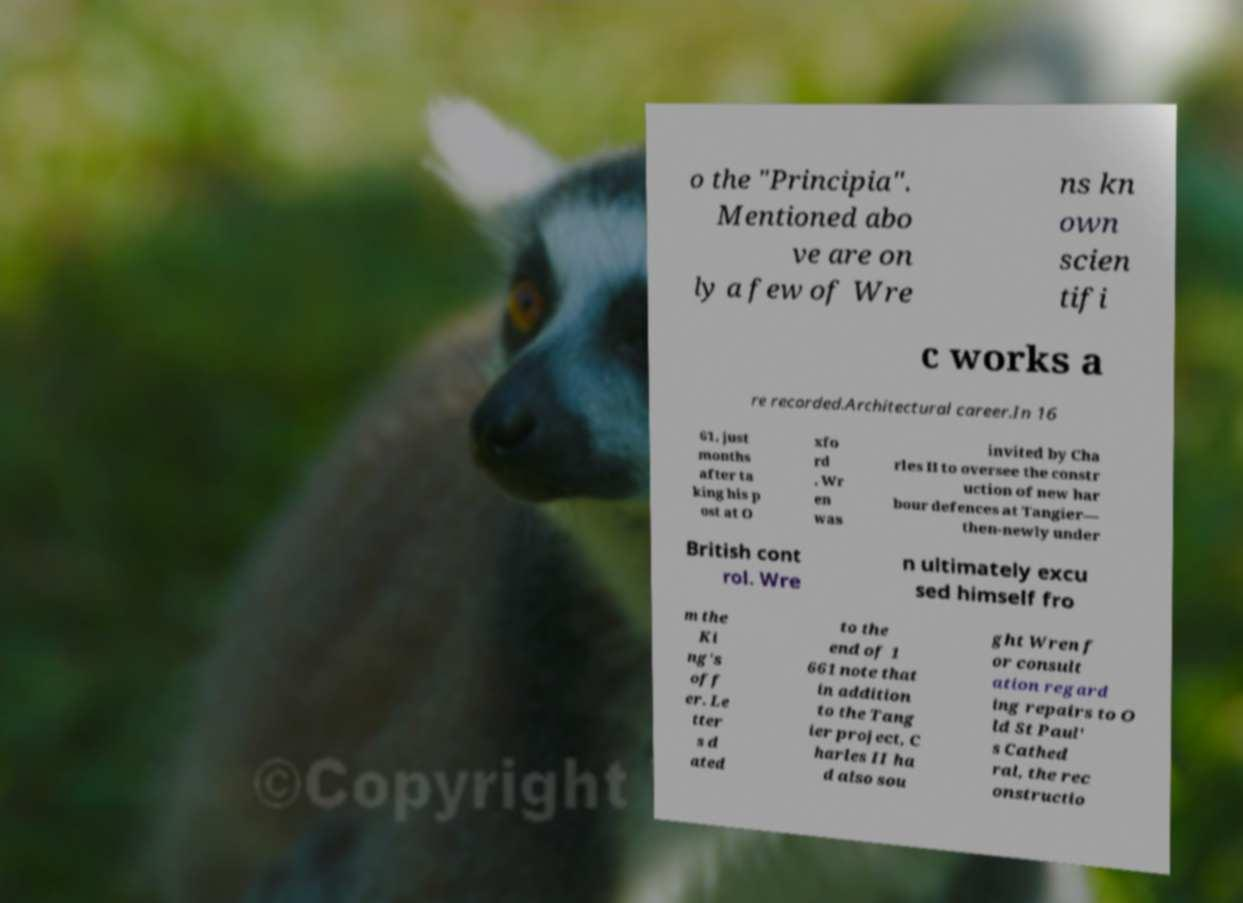Could you extract and type out the text from this image? o the "Principia". Mentioned abo ve are on ly a few of Wre ns kn own scien tifi c works a re recorded.Architectural career.In 16 61, just months after ta king his p ost at O xfo rd , Wr en was invited by Cha rles II to oversee the constr uction of new har bour defences at Tangier— then-newly under British cont rol. Wre n ultimately excu sed himself fro m the Ki ng's off er. Le tter s d ated to the end of 1 661 note that in addition to the Tang ier project, C harles II ha d also sou ght Wren f or consult ation regard ing repairs to O ld St Paul' s Cathed ral, the rec onstructio 